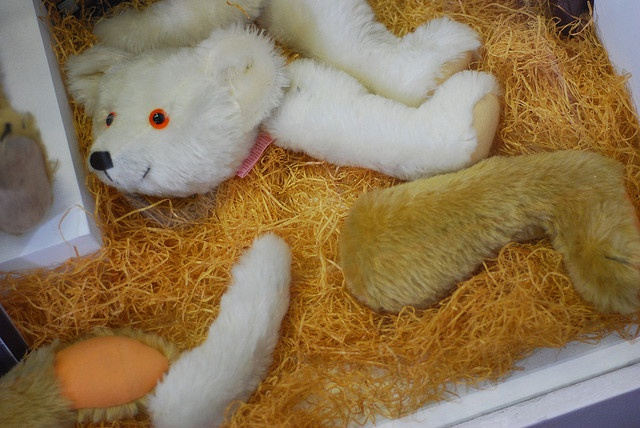Describe the objects in this image and their specific colors. I can see a teddy bear in gray, darkgray, and lightgray tones in this image. 